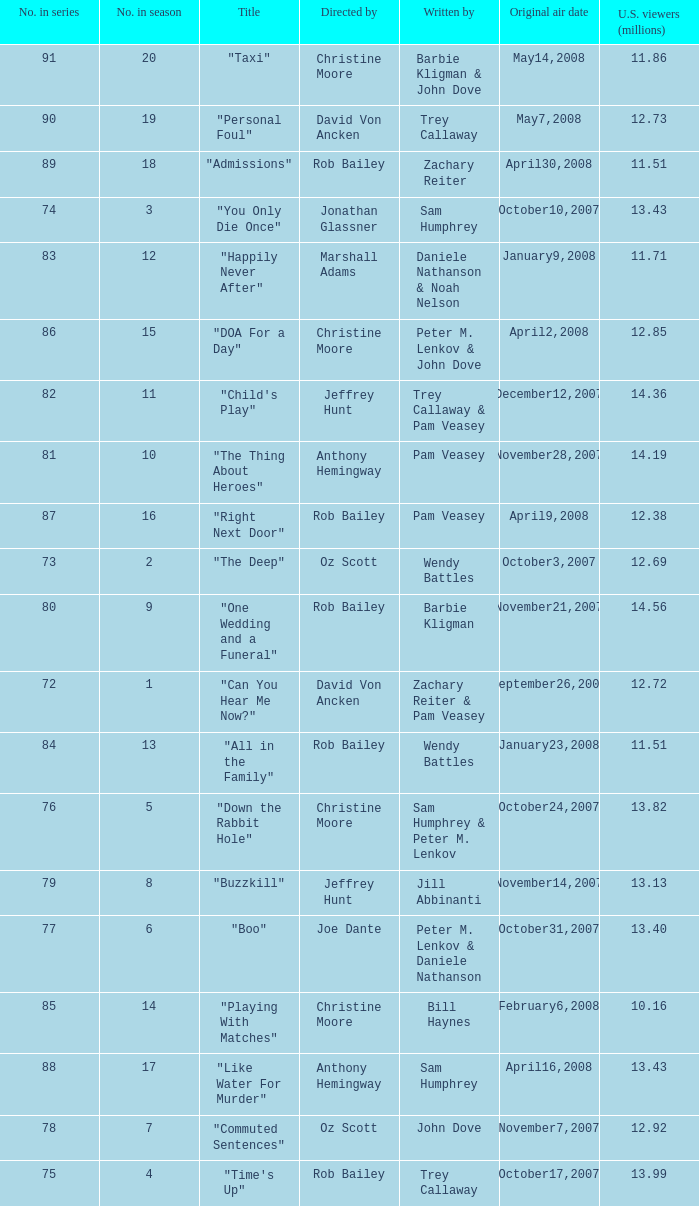How many million viewers from the u.s. saw the "buzzkill" episode? 1.0. Could you parse the entire table? {'header': ['No. in series', 'No. in season', 'Title', 'Directed by', 'Written by', 'Original air date', 'U.S. viewers (millions)'], 'rows': [['91', '20', '"Taxi"', 'Christine Moore', 'Barbie Kligman & John Dove', 'May14,2008', '11.86'], ['90', '19', '"Personal Foul"', 'David Von Ancken', 'Trey Callaway', 'May7,2008', '12.73'], ['89', '18', '"Admissions"', 'Rob Bailey', 'Zachary Reiter', 'April30,2008', '11.51'], ['74', '3', '"You Only Die Once"', 'Jonathan Glassner', 'Sam Humphrey', 'October10,2007', '13.43'], ['83', '12', '"Happily Never After"', 'Marshall Adams', 'Daniele Nathanson & Noah Nelson', 'January9,2008', '11.71'], ['86', '15', '"DOA For a Day"', 'Christine Moore', 'Peter M. Lenkov & John Dove', 'April2,2008', '12.85'], ['82', '11', '"Child\'s Play"', 'Jeffrey Hunt', 'Trey Callaway & Pam Veasey', 'December12,2007', '14.36'], ['81', '10', '"The Thing About Heroes"', 'Anthony Hemingway', 'Pam Veasey', 'November28,2007', '14.19'], ['87', '16', '"Right Next Door"', 'Rob Bailey', 'Pam Veasey', 'April9,2008', '12.38'], ['73', '2', '"The Deep"', 'Oz Scott', 'Wendy Battles', 'October3,2007', '12.69'], ['80', '9', '"One Wedding and a Funeral"', 'Rob Bailey', 'Barbie Kligman', 'November21,2007', '14.56'], ['72', '1', '"Can You Hear Me Now?"', 'David Von Ancken', 'Zachary Reiter & Pam Veasey', 'September26,2007', '12.72'], ['84', '13', '"All in the Family"', 'Rob Bailey', 'Wendy Battles', 'January23,2008', '11.51'], ['76', '5', '"Down the Rabbit Hole"', 'Christine Moore', 'Sam Humphrey & Peter M. Lenkov', 'October24,2007', '13.82'], ['79', '8', '"Buzzkill"', 'Jeffrey Hunt', 'Jill Abbinanti', 'November14,2007', '13.13'], ['77', '6', '"Boo"', 'Joe Dante', 'Peter M. Lenkov & Daniele Nathanson', 'October31,2007', '13.40'], ['85', '14', '"Playing With Matches"', 'Christine Moore', 'Bill Haynes', 'February6,2008', '10.16'], ['88', '17', '"Like Water For Murder"', 'Anthony Hemingway', 'Sam Humphrey', 'April16,2008', '13.43'], ['78', '7', '"Commuted Sentences"', 'Oz Scott', 'John Dove', 'November7,2007', '12.92'], ['75', '4', '"Time\'s Up"', 'Rob Bailey', 'Trey Callaway', 'October17,2007', '13.99']]} 